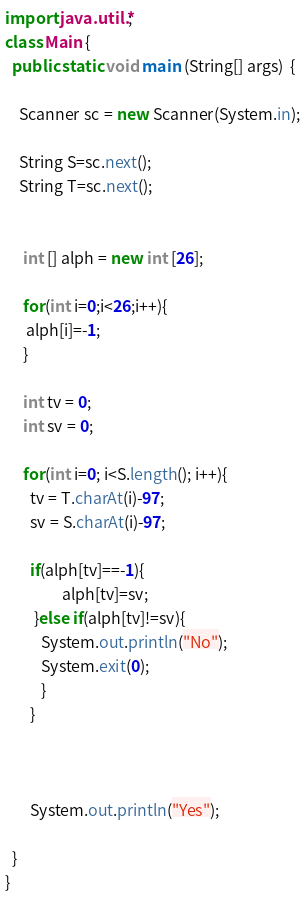Convert code to text. <code><loc_0><loc_0><loc_500><loc_500><_Java_>import java.util.*;
class Main {
  public static void main (String[] args)  {
    
    Scanner sc = new Scanner(System.in);
    
    String S=sc.next();
    String T=sc.next();
    
     
     int [] alph = new int [26];
     
     for(int i=0;i<26;i++){
      alph[i]=-1;
     }
     
     int tv = 0;
     int sv = 0;
     
     for(int i=0; i<S.length(); i++){
       tv = T.charAt(i)-97;
       sv = S.charAt(i)-97;
       
       if(alph[tv]==-1){
                alph[tv]=sv;
        }else if(alph[tv]!=sv){
          System.out.println("No");
          System.exit(0);
          }
       }
     
     
        
       System.out.println("Yes");
       
  }
}</code> 